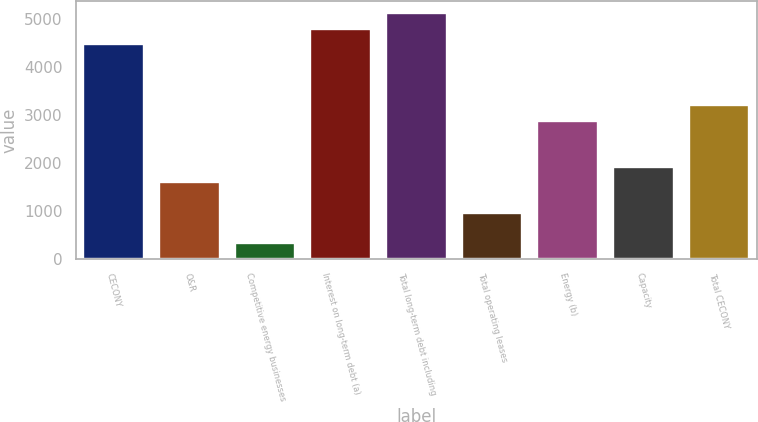Convert chart. <chart><loc_0><loc_0><loc_500><loc_500><bar_chart><fcel>CECONY<fcel>O&R<fcel>Competitive energy businesses<fcel>Interest on long-term debt (a)<fcel>Total long-term debt including<fcel>Total operating leases<fcel>Energy (b)<fcel>Capacity<fcel>Total CECONY<nl><fcel>4472.4<fcel>1600.5<fcel>324.1<fcel>4791.5<fcel>5110.6<fcel>962.3<fcel>2876.9<fcel>1919.6<fcel>3196<nl></chart> 